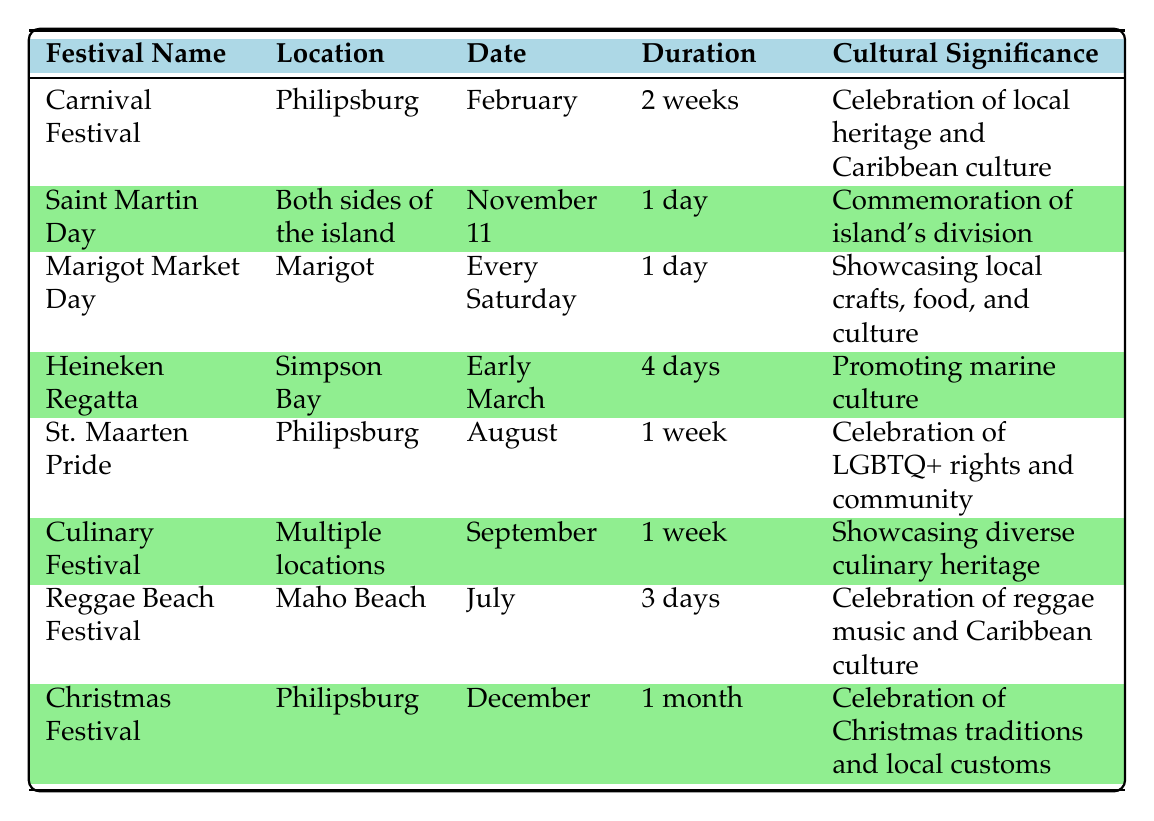What is the duration of the Carnival Festival? The table specifies that the Carnival Festival lasts for 2 weeks as listed under the "Duration" column.
Answer: 2 weeks How many days does the Reggae Beach Festival last? According to the table, the Reggae Beach Festival lasts for 3 days, as indicated in the "Duration" column.
Answer: 3 days Which festival occurs on November 11? The table identifies "Saint Martin Day" as taking place on November 11 under the "Date" column.
Answer: Saint Martin Day Is the Heineken Regatta celebrated in Philipsburg? The table shows that the Heineken Regatta is located in Simpson Bay, not Philipsburg, indicating that this statement is false.
Answer: No Which festival takes place every Saturday? The Marigot Market Day is the only festival listed that occurs "Every Saturday" under the "Date" column.
Answer: Marigot Market Day What is the cultural significance of the Culinary Festival? The table states that the Cultural Festival showcases the diverse culinary heritage of the island, which is its cultural significance.
Answer: Showcasing diverse culinary heritage How many festivals last for one week? Looking at the table, the "St. Maarten Pride" and "Culinary Festival" both last for 1 week, totaling 2 festivals.
Answer: 2 festivals Which festival has the longest duration? Upon reviewing the "Duration" column, it is evident that the Christmas Festival lasts for 1 month, making it the longest.
Answer: Christmas Festival What is the location of the Heineken Regatta? The table specifies Simpson Bay as the location of the Heineken Regatta.
Answer: Simpson Bay What is the total duration of festivals held in July? The Reggae Beach Festival is the only festival listed that occurs in July lasting for 3 days, which is also the total duration for July.
Answer: 3 days How many events celebrate Caribbean culture? The table lists three festivals (Carnival Festival, Heineken Regatta, and Reggae Beach Festival) that emphasize Caribbean culture as part of their cultural significance.
Answer: 3 events 